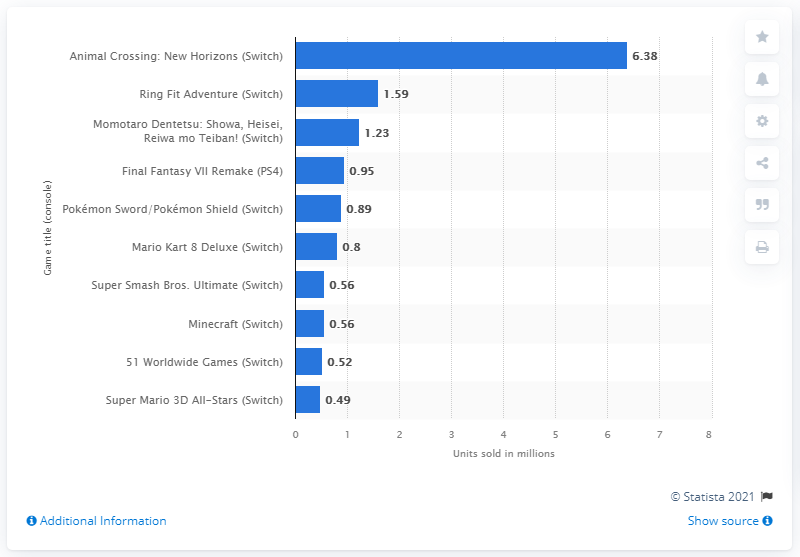Mention a couple of crucial points in this snapshot. Animal Crossing: New Horizons sold 6,380 units in Japan in 2020. 